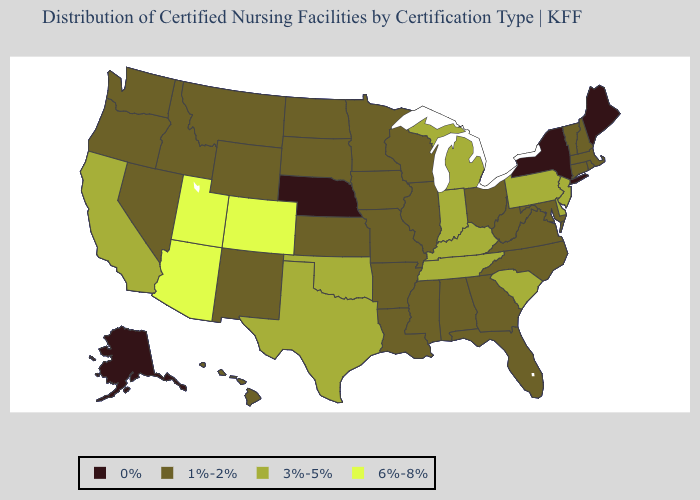Name the states that have a value in the range 3%-5%?
Be succinct. California, Delaware, Indiana, Kentucky, Michigan, New Jersey, Oklahoma, Pennsylvania, South Carolina, Tennessee, Texas. Which states have the lowest value in the South?
Keep it brief. Alabama, Arkansas, Florida, Georgia, Louisiana, Maryland, Mississippi, North Carolina, Virginia, West Virginia. What is the lowest value in the USA?
Give a very brief answer. 0%. Name the states that have a value in the range 3%-5%?
Be succinct. California, Delaware, Indiana, Kentucky, Michigan, New Jersey, Oklahoma, Pennsylvania, South Carolina, Tennessee, Texas. What is the highest value in states that border Mississippi?
Quick response, please. 3%-5%. What is the lowest value in states that border Virginia?
Short answer required. 1%-2%. Name the states that have a value in the range 1%-2%?
Write a very short answer. Alabama, Arkansas, Connecticut, Florida, Georgia, Hawaii, Idaho, Illinois, Iowa, Kansas, Louisiana, Maryland, Massachusetts, Minnesota, Mississippi, Missouri, Montana, Nevada, New Hampshire, New Mexico, North Carolina, North Dakota, Ohio, Oregon, Rhode Island, South Dakota, Vermont, Virginia, Washington, West Virginia, Wisconsin, Wyoming. Name the states that have a value in the range 0%?
Write a very short answer. Alaska, Maine, Nebraska, New York. Name the states that have a value in the range 6%-8%?
Short answer required. Arizona, Colorado, Utah. What is the highest value in states that border Washington?
Quick response, please. 1%-2%. Is the legend a continuous bar?
Quick response, please. No. Which states have the lowest value in the USA?
Give a very brief answer. Alaska, Maine, Nebraska, New York. What is the highest value in states that border Mississippi?
Short answer required. 3%-5%. Among the states that border Vermont , which have the lowest value?
Give a very brief answer. New York. Name the states that have a value in the range 3%-5%?
Give a very brief answer. California, Delaware, Indiana, Kentucky, Michigan, New Jersey, Oklahoma, Pennsylvania, South Carolina, Tennessee, Texas. 